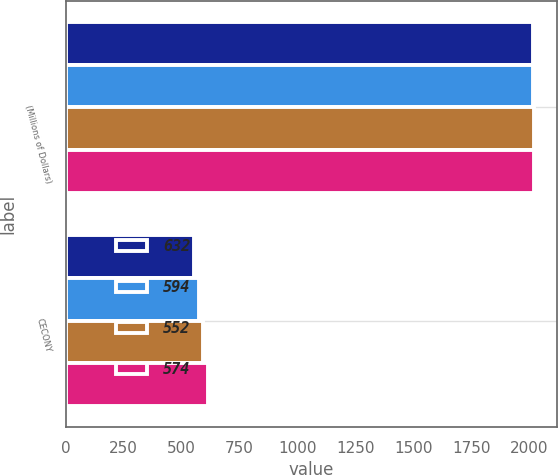<chart> <loc_0><loc_0><loc_500><loc_500><stacked_bar_chart><ecel><fcel>(Millions of Dollars)<fcel>CECONY<nl><fcel>632<fcel>2015<fcel>552<nl><fcel>594<fcel>2016<fcel>574<nl><fcel>552<fcel>2017<fcel>594<nl><fcel>574<fcel>2018<fcel>613<nl></chart> 